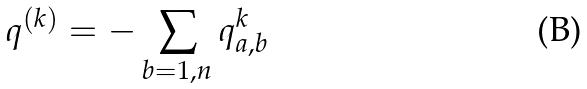Convert formula to latex. <formula><loc_0><loc_0><loc_500><loc_500>q ^ { ( k ) } = - \sum _ { b = 1 , n } q _ { a , b } ^ { k }</formula> 